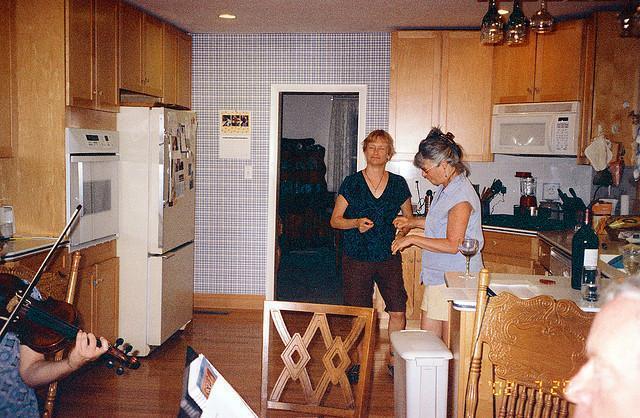What instrument is the person on the left playing?
Indicate the correct response by choosing from the four available options to answer the question.
Options: Banjo, harp, violin, guitar. Violin. 